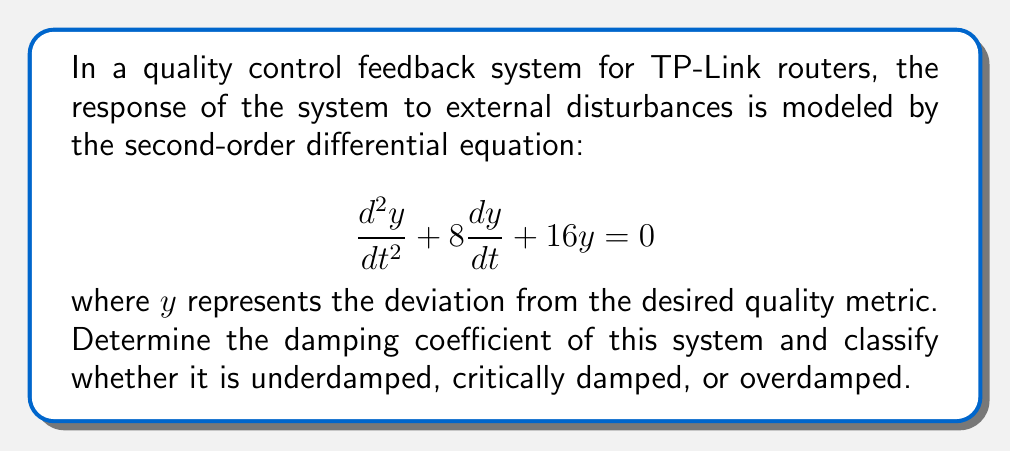Provide a solution to this math problem. To solve this problem, we need to follow these steps:

1) The general form of a second-order linear differential equation is:

   $$\frac{d^2y}{dt^2} + 2\zeta\omega_n\frac{dy}{dt} + \omega_n^2y = 0$$

   where $\zeta$ is the damping ratio and $\omega_n$ is the natural frequency.

2) Comparing our equation to the general form:

   $$\frac{d^2y}{dt^2} + 8\frac{dy}{dt} + 16y = 0$$

   We can see that $2\zeta\omega_n = 8$ and $\omega_n^2 = 16$

3) From $\omega_n^2 = 16$, we can determine that $\omega_n = 4$ (since $\omega_n$ is always positive).

4) Now we can solve for $\zeta$:

   $2\zeta\omega_n = 8$
   $2\zeta(4) = 8$
   $\zeta = 1$

5) The damping coefficient is defined as $c = 2\zeta\omega_n$. We already know this value is 8 from our original equation.

6) To classify the system:
   - If $\zeta < 1$, the system is underdamped
   - If $\zeta = 1$, the system is critically damped
   - If $\zeta > 1$, the system is overdamped

   Since $\zeta = 1$, this system is critically damped.
Answer: The damping coefficient is 8, and the system is critically damped. 